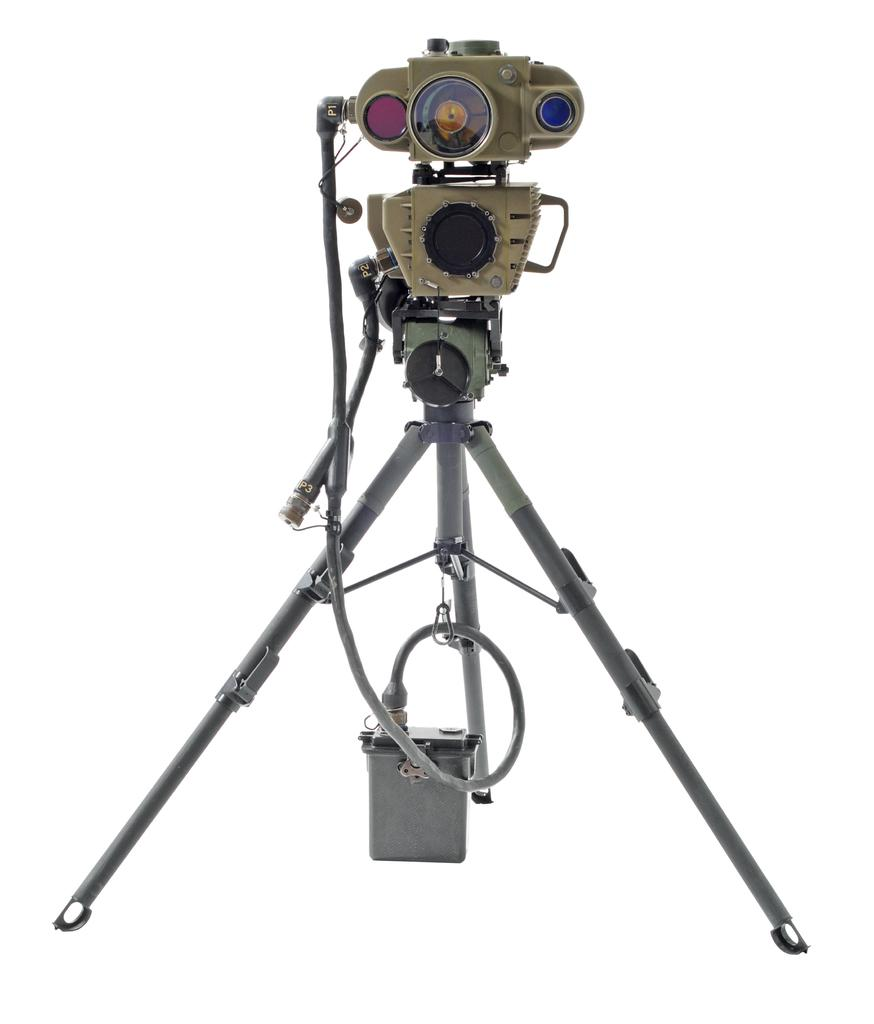What is the main object in the image? There is a camera in the image. Is there any equipment related to the camera in the image? Yes, there is a camera stand in the image. What color is the background of the image? The background of the image is white. What type of mint can be seen growing in the wilderness in the image? There is no wilderness or mint present in the image; it features a camera and a camera stand against a white background. 